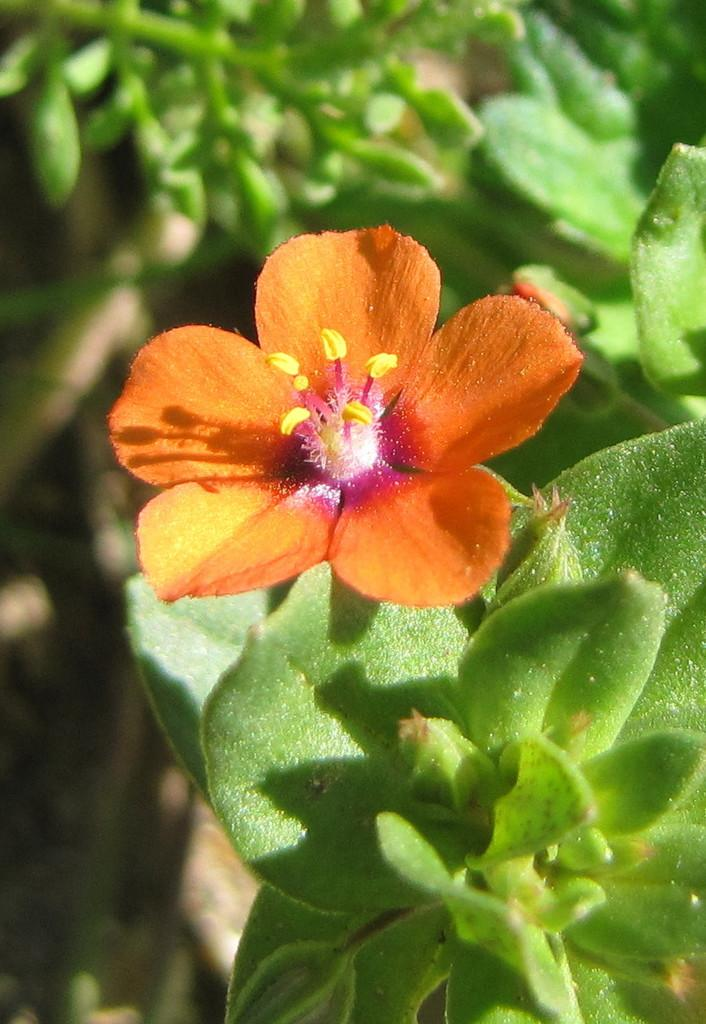What can be seen in the foreground of the picture? There are leaves and a flower in the foreground of the picture. What type of vegetation is present in the foreground? The foreground contains leaves and a flower. What can be seen in the background of the picture? There is greenery in the background of the picture. How is the background depicted in the image? The background is mostly blurred. How many parents are visible in the picture? There are no parents present in the picture; it features leaves, a flower, and greenery. What type of flowers can be seen in the background of the picture? There are no flowers visible in the background of the picture; only greenery is present. 